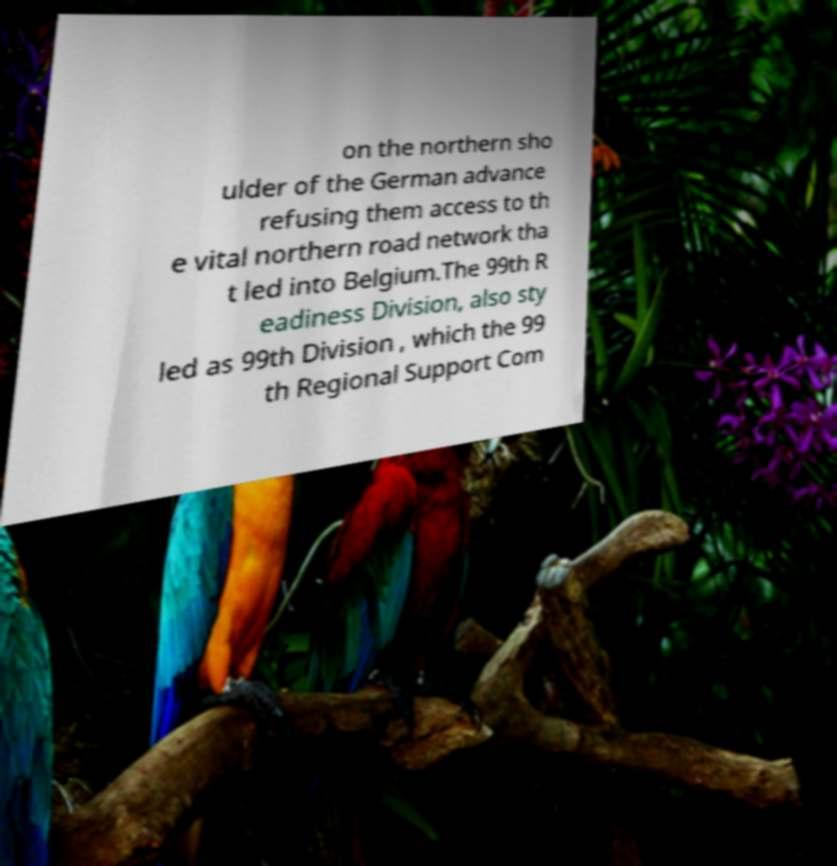Can you read and provide the text displayed in the image?This photo seems to have some interesting text. Can you extract and type it out for me? on the northern sho ulder of the German advance refusing them access to th e vital northern road network tha t led into Belgium.The 99th R eadiness Division, also sty led as 99th Division , which the 99 th Regional Support Com 